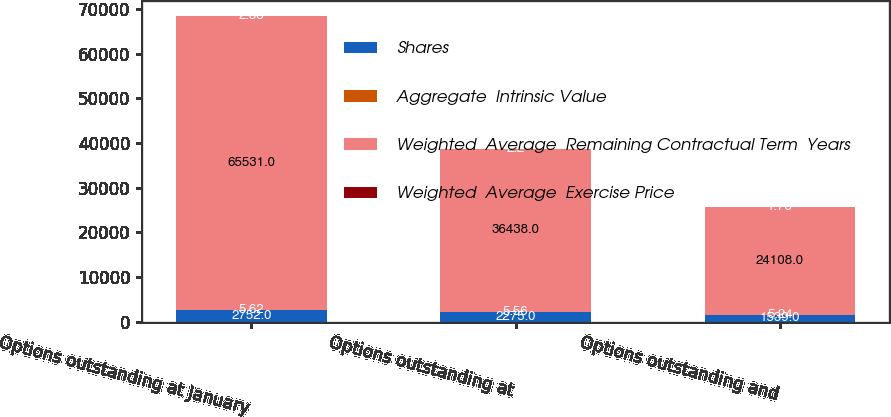<chart> <loc_0><loc_0><loc_500><loc_500><stacked_bar_chart><ecel><fcel>Options outstanding at January<fcel>Options outstanding at<fcel>Options outstanding and<nl><fcel>Shares<fcel>2752<fcel>2275<fcel>1539<nl><fcel>Aggregate  Intrinsic Value<fcel>5.62<fcel>5.56<fcel>5.24<nl><fcel>Weighted  Average  Remaining Contractual Term  Years<fcel>65531<fcel>36438<fcel>24108<nl><fcel>Weighted  Average  Exercise Price<fcel>2.88<fcel>2.2<fcel>1.76<nl></chart> 